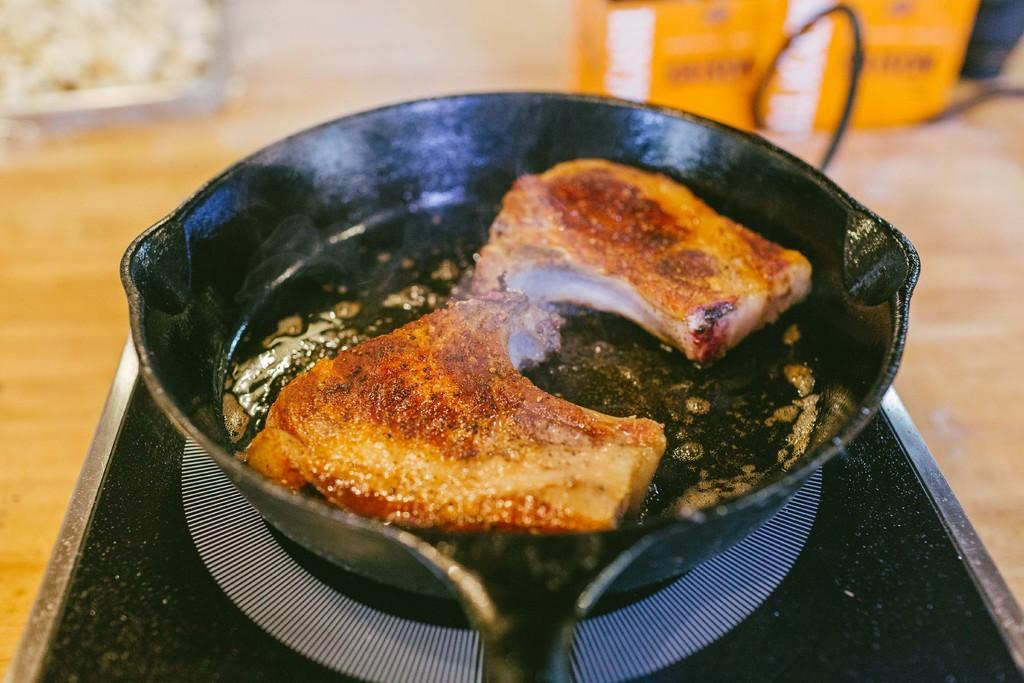What is in the pan that is visible in the image? There is a food item in a pan in the image. What type of cooking surface is present in the image? There is an induction cooktop in the image. What type of soda can be seen being poured into the pan in the image? There is no soda present in the image; it features a food item in a pan on an induction cooktop. Can you hear the voice of the person cooking in the image? The image is silent, and there is no indication of a person's voice being present. 